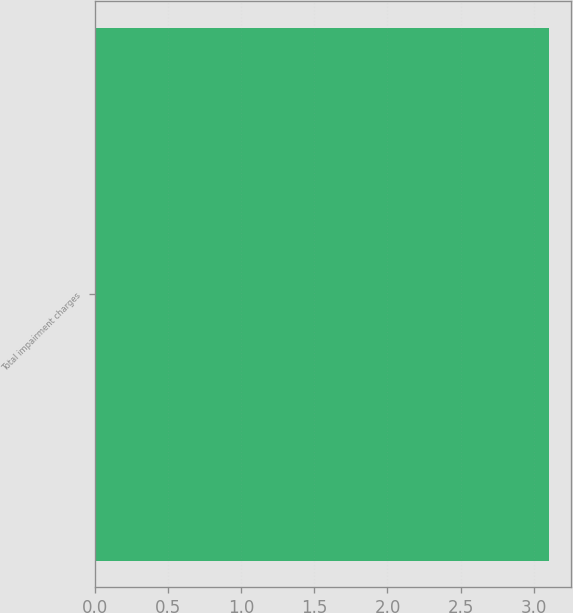Convert chart. <chart><loc_0><loc_0><loc_500><loc_500><bar_chart><fcel>Total impairment charges<nl><fcel>3.1<nl></chart> 